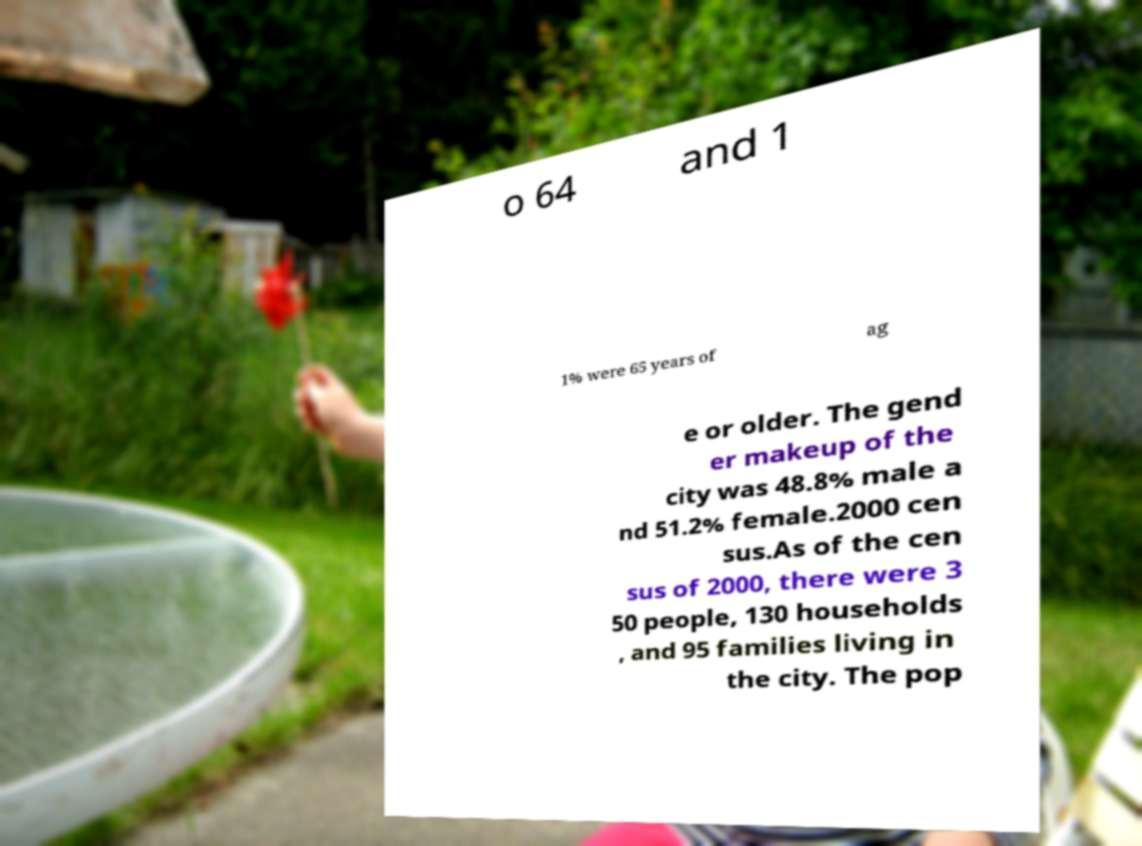Can you accurately transcribe the text from the provided image for me? o 64 and 1 1% were 65 years of ag e or older. The gend er makeup of the city was 48.8% male a nd 51.2% female.2000 cen sus.As of the cen sus of 2000, there were 3 50 people, 130 households , and 95 families living in the city. The pop 